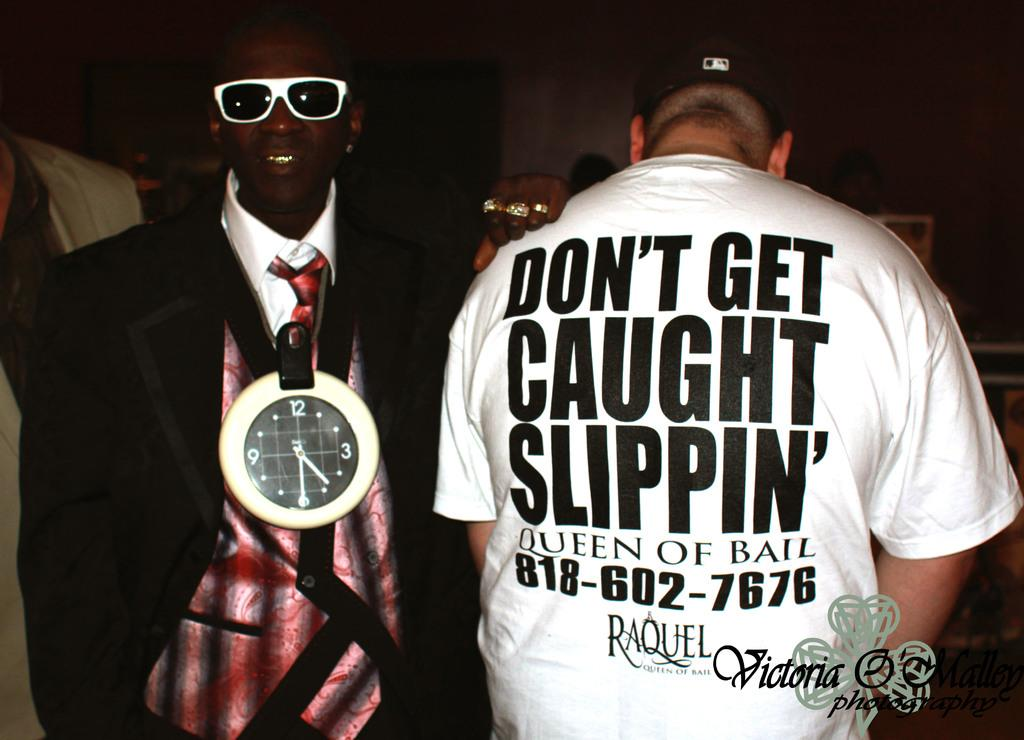Provide a one-sentence caption for the provided image. Two men, one of which has a shirt with the words don't get caught slippin' written on its back. 